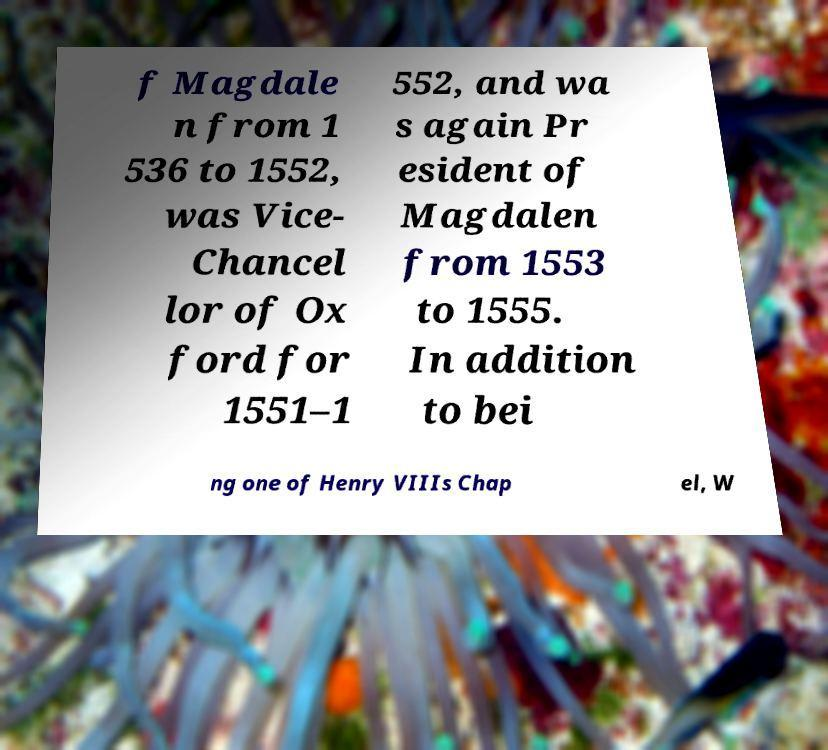Could you extract and type out the text from this image? f Magdale n from 1 536 to 1552, was Vice- Chancel lor of Ox ford for 1551–1 552, and wa s again Pr esident of Magdalen from 1553 to 1555. In addition to bei ng one of Henry VIIIs Chap el, W 